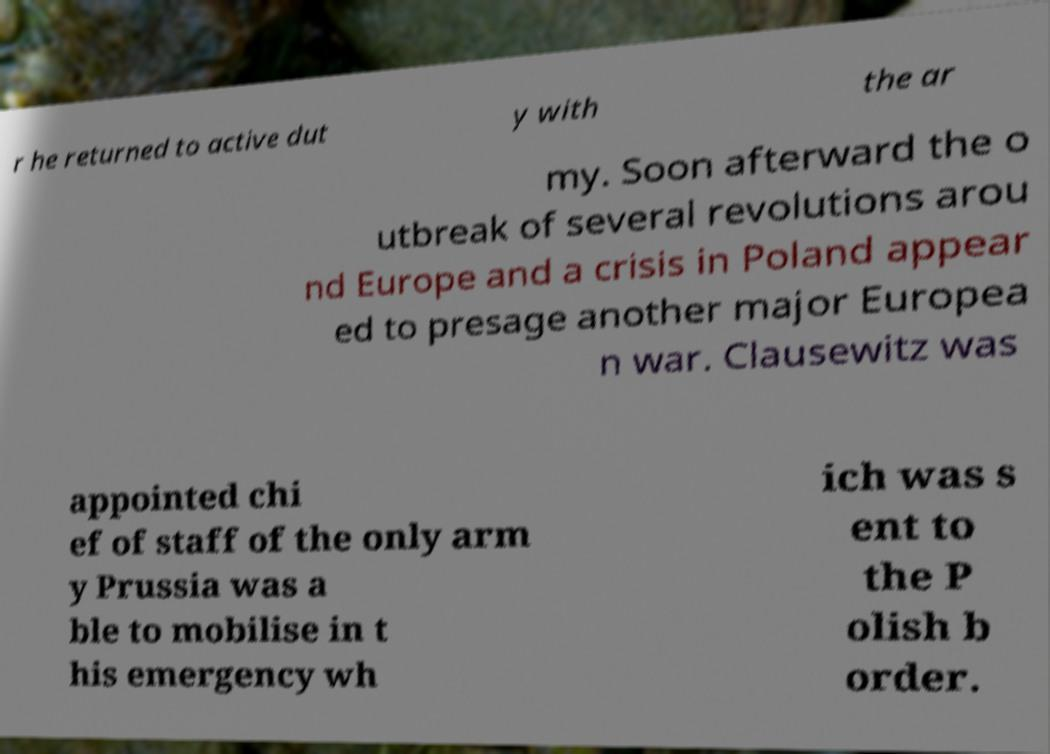What messages or text are displayed in this image? I need them in a readable, typed format. r he returned to active dut y with the ar my. Soon afterward the o utbreak of several revolutions arou nd Europe and a crisis in Poland appear ed to presage another major Europea n war. Clausewitz was appointed chi ef of staff of the only arm y Prussia was a ble to mobilise in t his emergency wh ich was s ent to the P olish b order. 